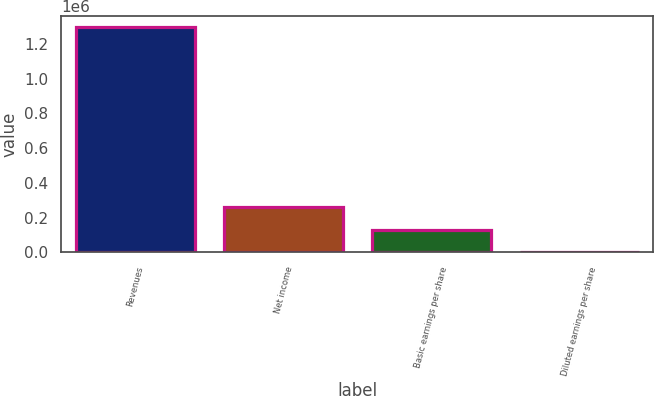Convert chart. <chart><loc_0><loc_0><loc_500><loc_500><bar_chart><fcel>Revenues<fcel>Net income<fcel>Basic earnings per share<fcel>Diluted earnings per share<nl><fcel>1.29629e+06<fcel>259259<fcel>129630<fcel>0.97<nl></chart> 